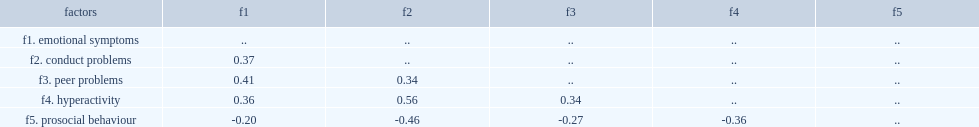Can you parse all the data within this table? {'header': ['factors', 'f1', 'f2', 'f3', 'f4', 'f5'], 'rows': [['f1. emotional symptoms', '..', '..', '..', '..', '..'], ['f2. conduct problems', '0.37', '..', '..', '..', '..'], ['f3. peer problems', '0.41', '0.34', '..', '..', '..'], ['f4. hyperactivity', '0.36', '0.56', '0.34', '..', '..'], ['f5. prosocial behaviour', '-0.20', '-0.46', '-0.27', '-0.36', '..']]} Which difficulties factors has positive correlations among all five factors? F1. emotional symptoms f2. conduct problems f3. peer problems f4. hyperactivity. Which factor correlated negatively with other four difficulties factors? F5. prosocial behaviour. 